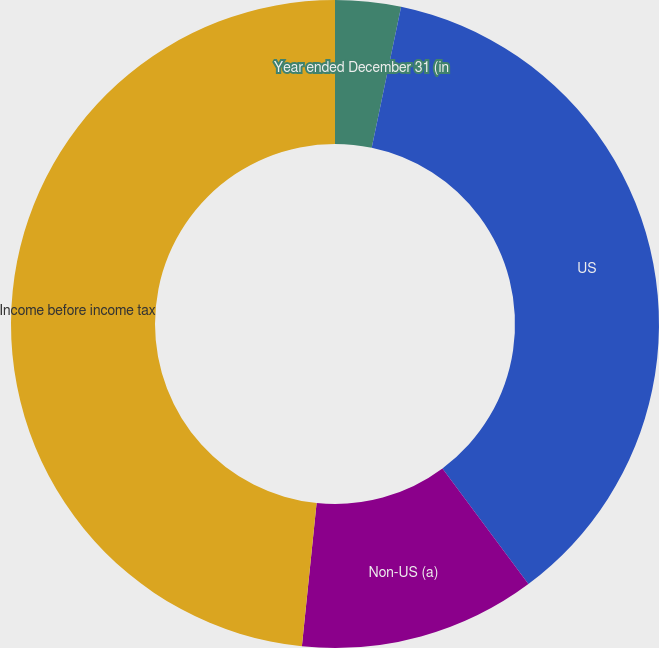Convert chart. <chart><loc_0><loc_0><loc_500><loc_500><pie_chart><fcel>Year ended December 31 (in<fcel>US<fcel>Non-US (a)<fcel>Income before income tax<nl><fcel>3.27%<fcel>36.55%<fcel>11.81%<fcel>48.37%<nl></chart> 